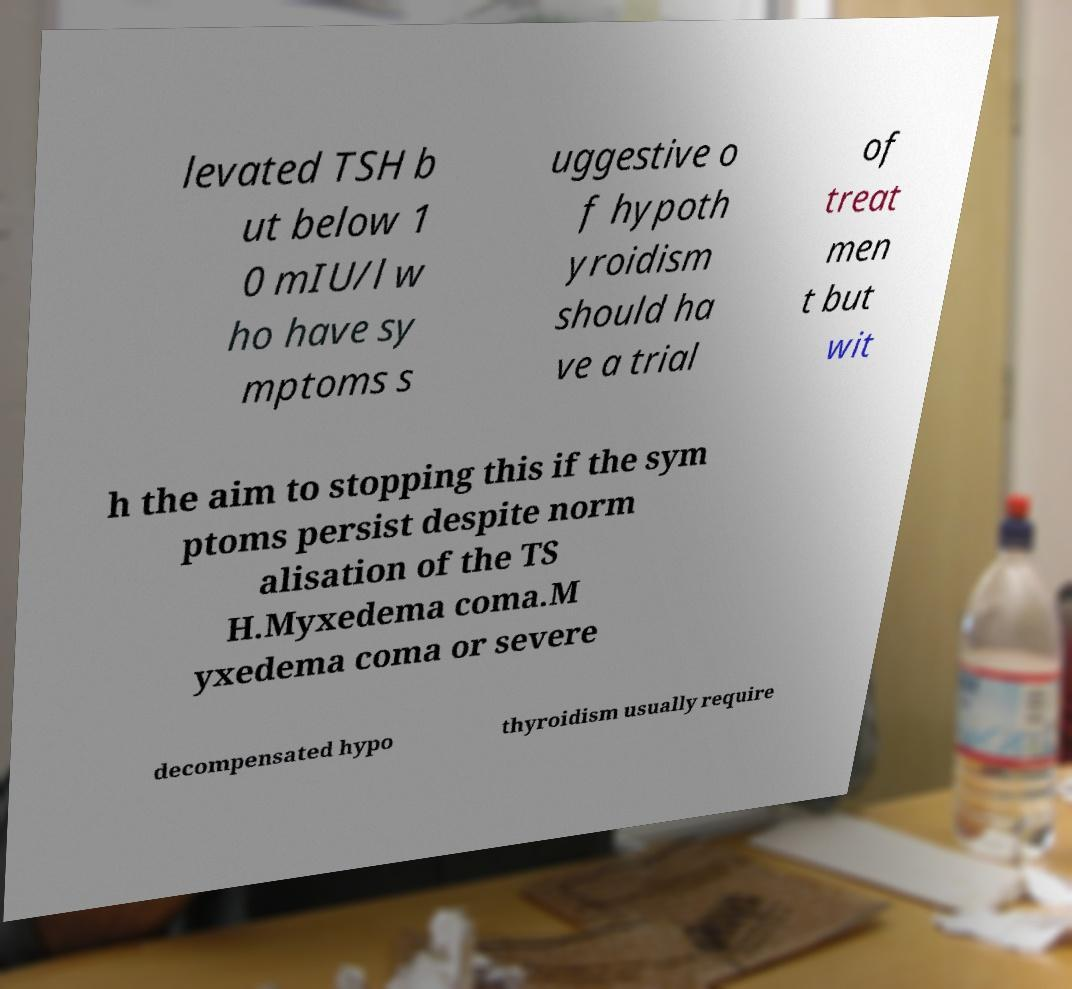Can you read and provide the text displayed in the image?This photo seems to have some interesting text. Can you extract and type it out for me? levated TSH b ut below 1 0 mIU/l w ho have sy mptoms s uggestive o f hypoth yroidism should ha ve a trial of treat men t but wit h the aim to stopping this if the sym ptoms persist despite norm alisation of the TS H.Myxedema coma.M yxedema coma or severe decompensated hypo thyroidism usually require 